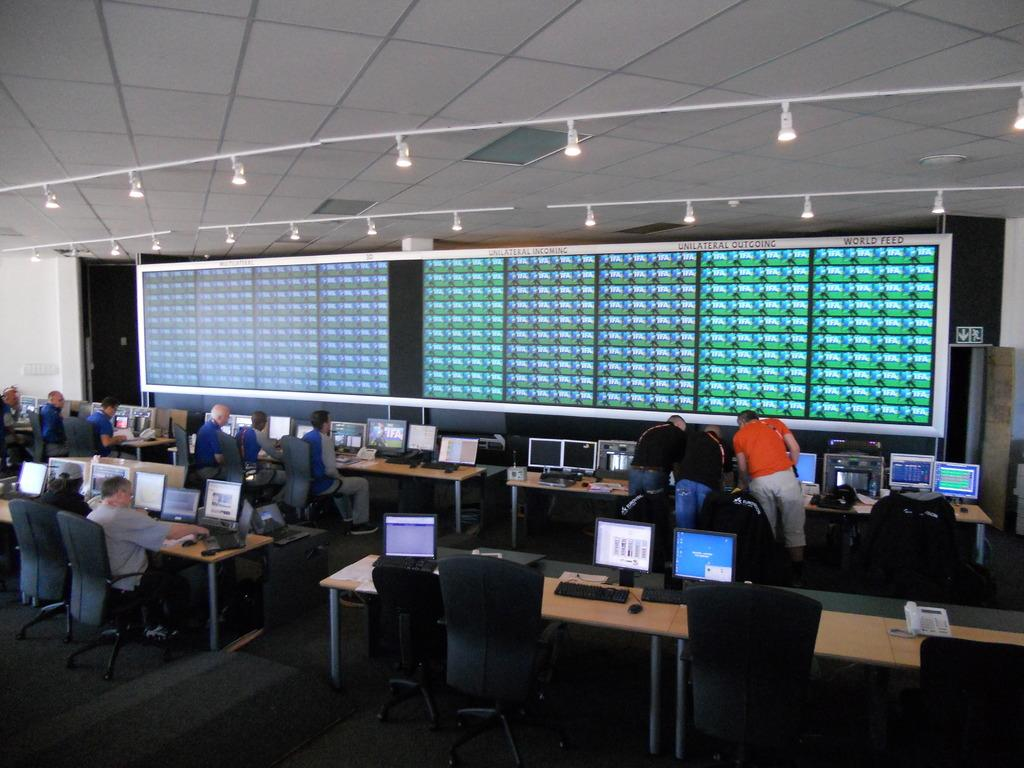How many persons are in the image? There is a group of persons in the image. What are the persons doing in the image? The persons are sitting in chairs. What objects are in front of the persons? There are tables in front of the persons. What is the main feature in front of the persons? There is a big screen in front of the persons. What can be seen on the big screen? Something is displayed on the big screen. How many cups are on the bed in the image? There is no bed or cups present in the image. 